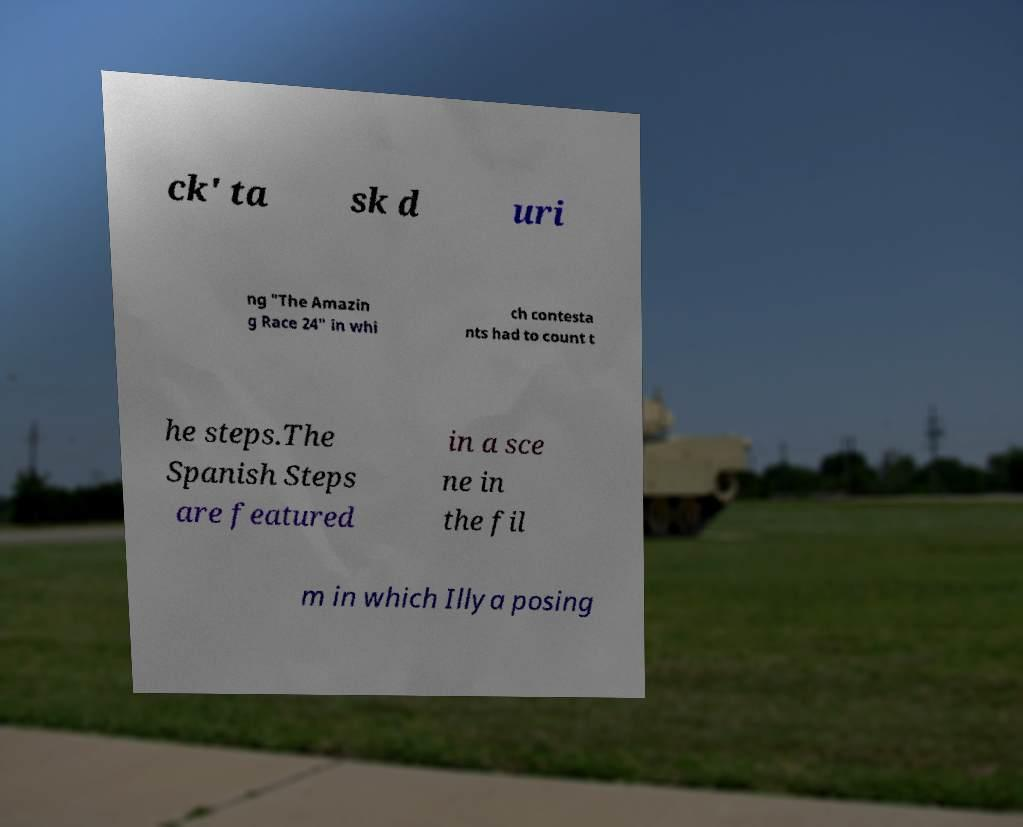Can you read and provide the text displayed in the image?This photo seems to have some interesting text. Can you extract and type it out for me? ck' ta sk d uri ng "The Amazin g Race 24" in whi ch contesta nts had to count t he steps.The Spanish Steps are featured in a sce ne in the fil m in which Illya posing 